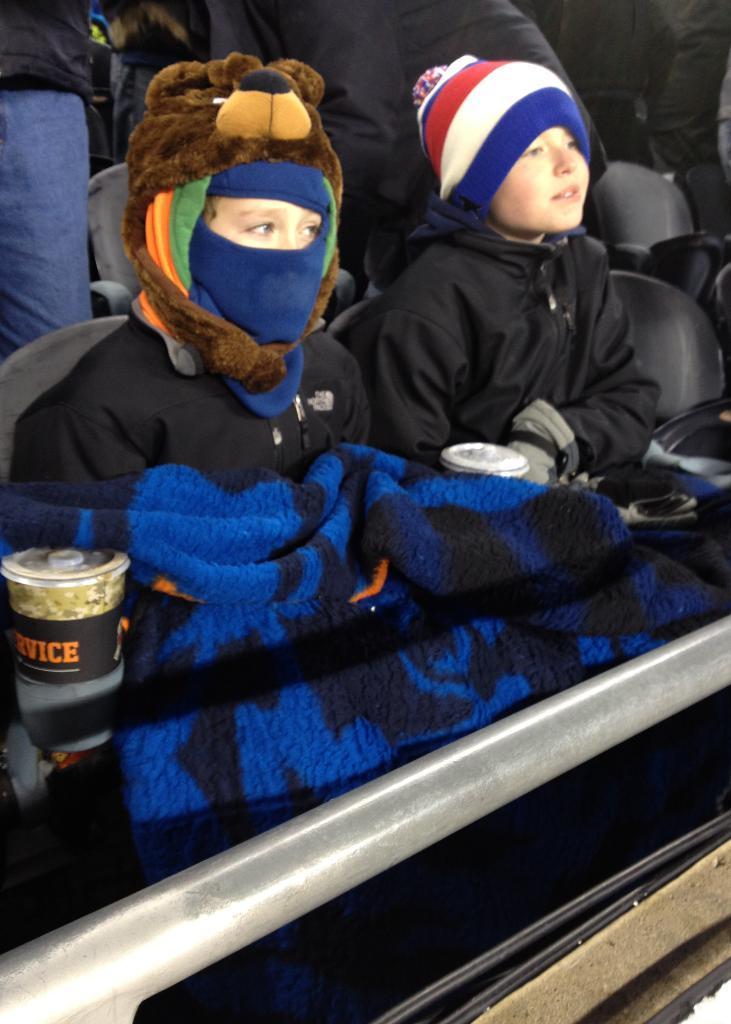Please provide a concise description of this image. In this image people are sitting on the chairs. Beside them there are food items. 